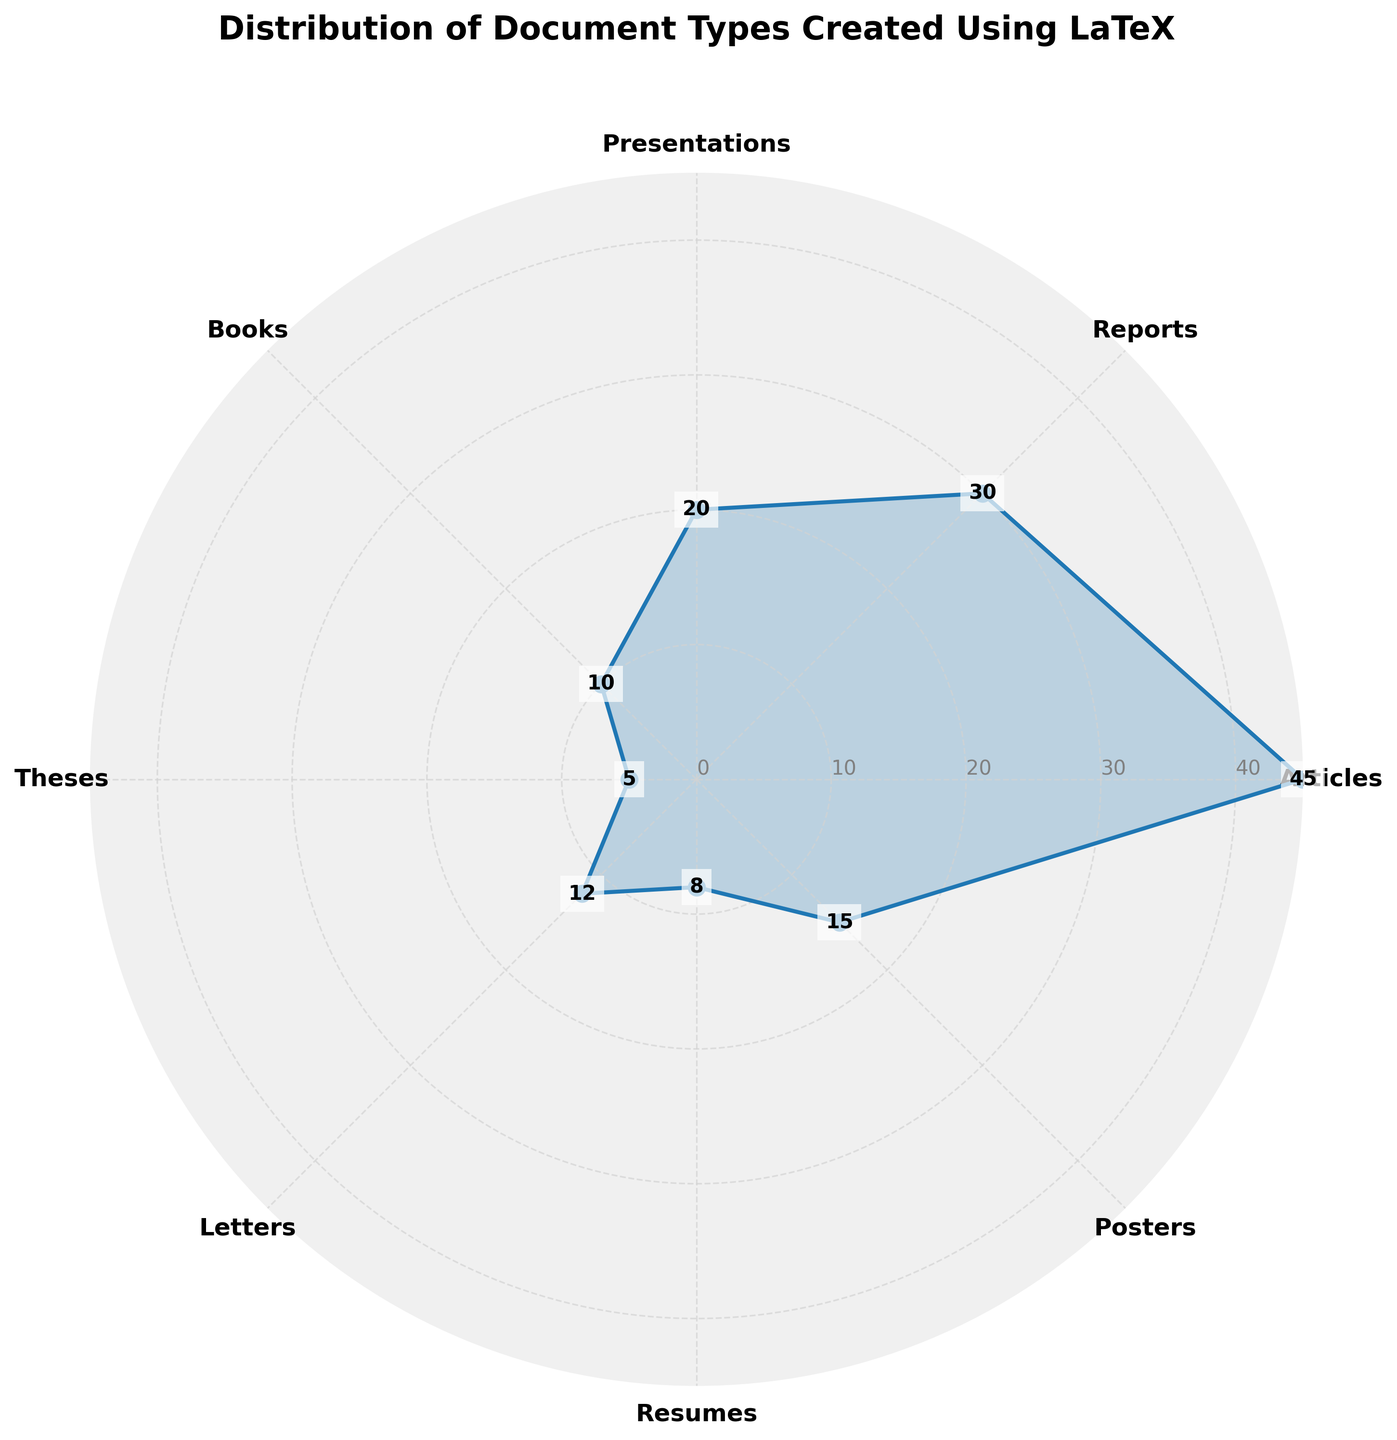What is the title of the figure? The title of the figure is mentioned at the top and usually gives an overview of what the figure represents. Here, it states "Distribution of Document Types Created Using LaTeX".
Answer: Distribution of Document Types Created Using LaTeX How many different document types are shown in the figure? Count the number of categories or segments that have labels in the polar area chart.
Answer: 8 Which document type has the highest count? Look for the segment with the largest radial extent or the label with the highest value. Articles have the highest count as their value reaches the maximum extent of the chart.
Answer: Articles What is the difference in count between Articles and Presentations? Look at the respective counts for Articles (45) and Presentations (20). Subtract the smaller count from the larger count. 45 - 20 = 25
Answer: 25 What is the total count of Reports and Posters combined? Find the individual counts for Reports (30) and Posters (15). Add these two values together. 30 + 15 = 45
Answer: 45 Which document type has the smallest count? Identify the segment with the smallest radial extent or the label with the smallest value. Theses have the smallest count with a value of 5.
Answer: Theses Are there more Resumes or Letters? Compare the values for Resumes (8) and Letters (12). Letters have a higher count than Resumes.
Answer: Letters What is the median count of all document types? Arrange the counts in ascending order (5, 8, 10, 12, 15, 20, 30, 45). Since there are 8 values, the median is the average of the 4th and 5th values. (12 + 15) / 2 = 13.5
Answer: 13.5 By how much does the count of Books exceed that of Theses? Compare the counts for Books (10) and Theses (5). Subtract the smaller count from the larger count. 10 - 5 = 5
Answer: 5 How are the radial grid lines spaced? Look at the radial grid lines in the polar chart. The grid lines appear to be spaced evenly at intervals of 10 units, starting from 0.
Answer: 10 units 